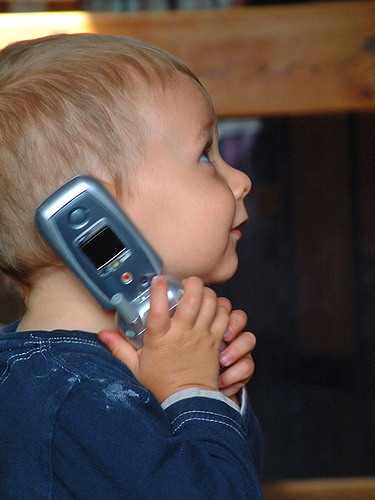Describe the objects in this image and their specific colors. I can see people in maroon, navy, gray, tan, and black tones and cell phone in maroon, blue, gray, navy, and black tones in this image. 